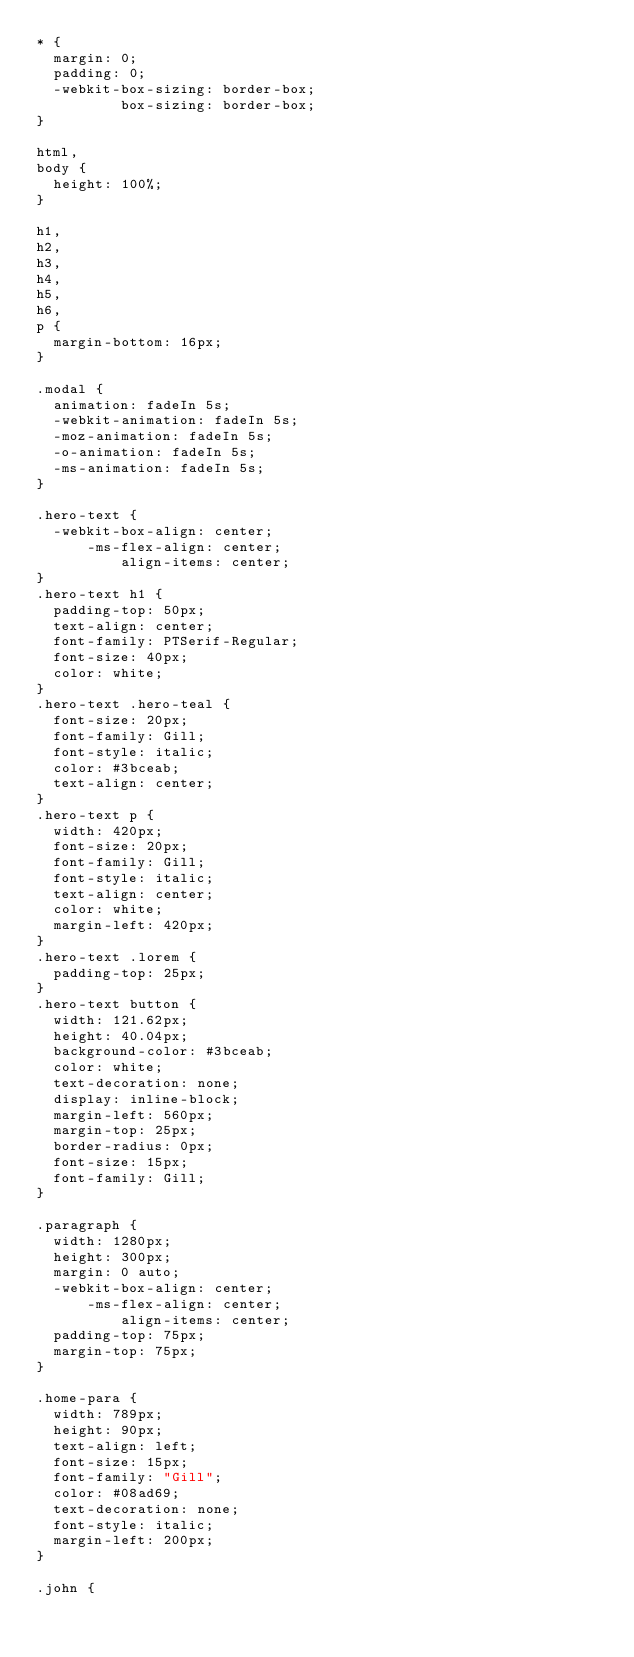<code> <loc_0><loc_0><loc_500><loc_500><_CSS_>* {
  margin: 0;
  padding: 0;
  -webkit-box-sizing: border-box;
          box-sizing: border-box;
}

html,
body {
  height: 100%;
}

h1,
h2,
h3,
h4,
h5,
h6,
p {
  margin-bottom: 16px;
}

.modal {
  animation: fadeIn 5s;
  -webkit-animation: fadeIn 5s;
  -moz-animation: fadeIn 5s;
  -o-animation: fadeIn 5s;
  -ms-animation: fadeIn 5s;
}

.hero-text {
  -webkit-box-align: center;
      -ms-flex-align: center;
          align-items: center;
}
.hero-text h1 {
  padding-top: 50px;
  text-align: center;
  font-family: PTSerif-Regular;
  font-size: 40px;
  color: white;
}
.hero-text .hero-teal {
  font-size: 20px;
  font-family: Gill;
  font-style: italic;
  color: #3bceab;
  text-align: center;
}
.hero-text p {
  width: 420px;
  font-size: 20px;
  font-family: Gill;
  font-style: italic;
  text-align: center;
  color: white;
  margin-left: 420px;
}
.hero-text .lorem {
  padding-top: 25px;
}
.hero-text button {
  width: 121.62px;
  height: 40.04px;
  background-color: #3bceab;
  color: white;
  text-decoration: none;
  display: inline-block;
  margin-left: 560px;
  margin-top: 25px;
  border-radius: 0px;
  font-size: 15px;
  font-family: Gill;
}

.paragraph {
  width: 1280px;
  height: 300px;
  margin: 0 auto;
  -webkit-box-align: center;
      -ms-flex-align: center;
          align-items: center;
  padding-top: 75px;
  margin-top: 75px;
}

.home-para {
  width: 789px;
  height: 90px;
  text-align: left;
  font-size: 15px;
  font-family: "Gill";
  color: #08ad69;
  text-decoration: none;
  font-style: italic;
  margin-left: 200px;
}

.john {</code> 